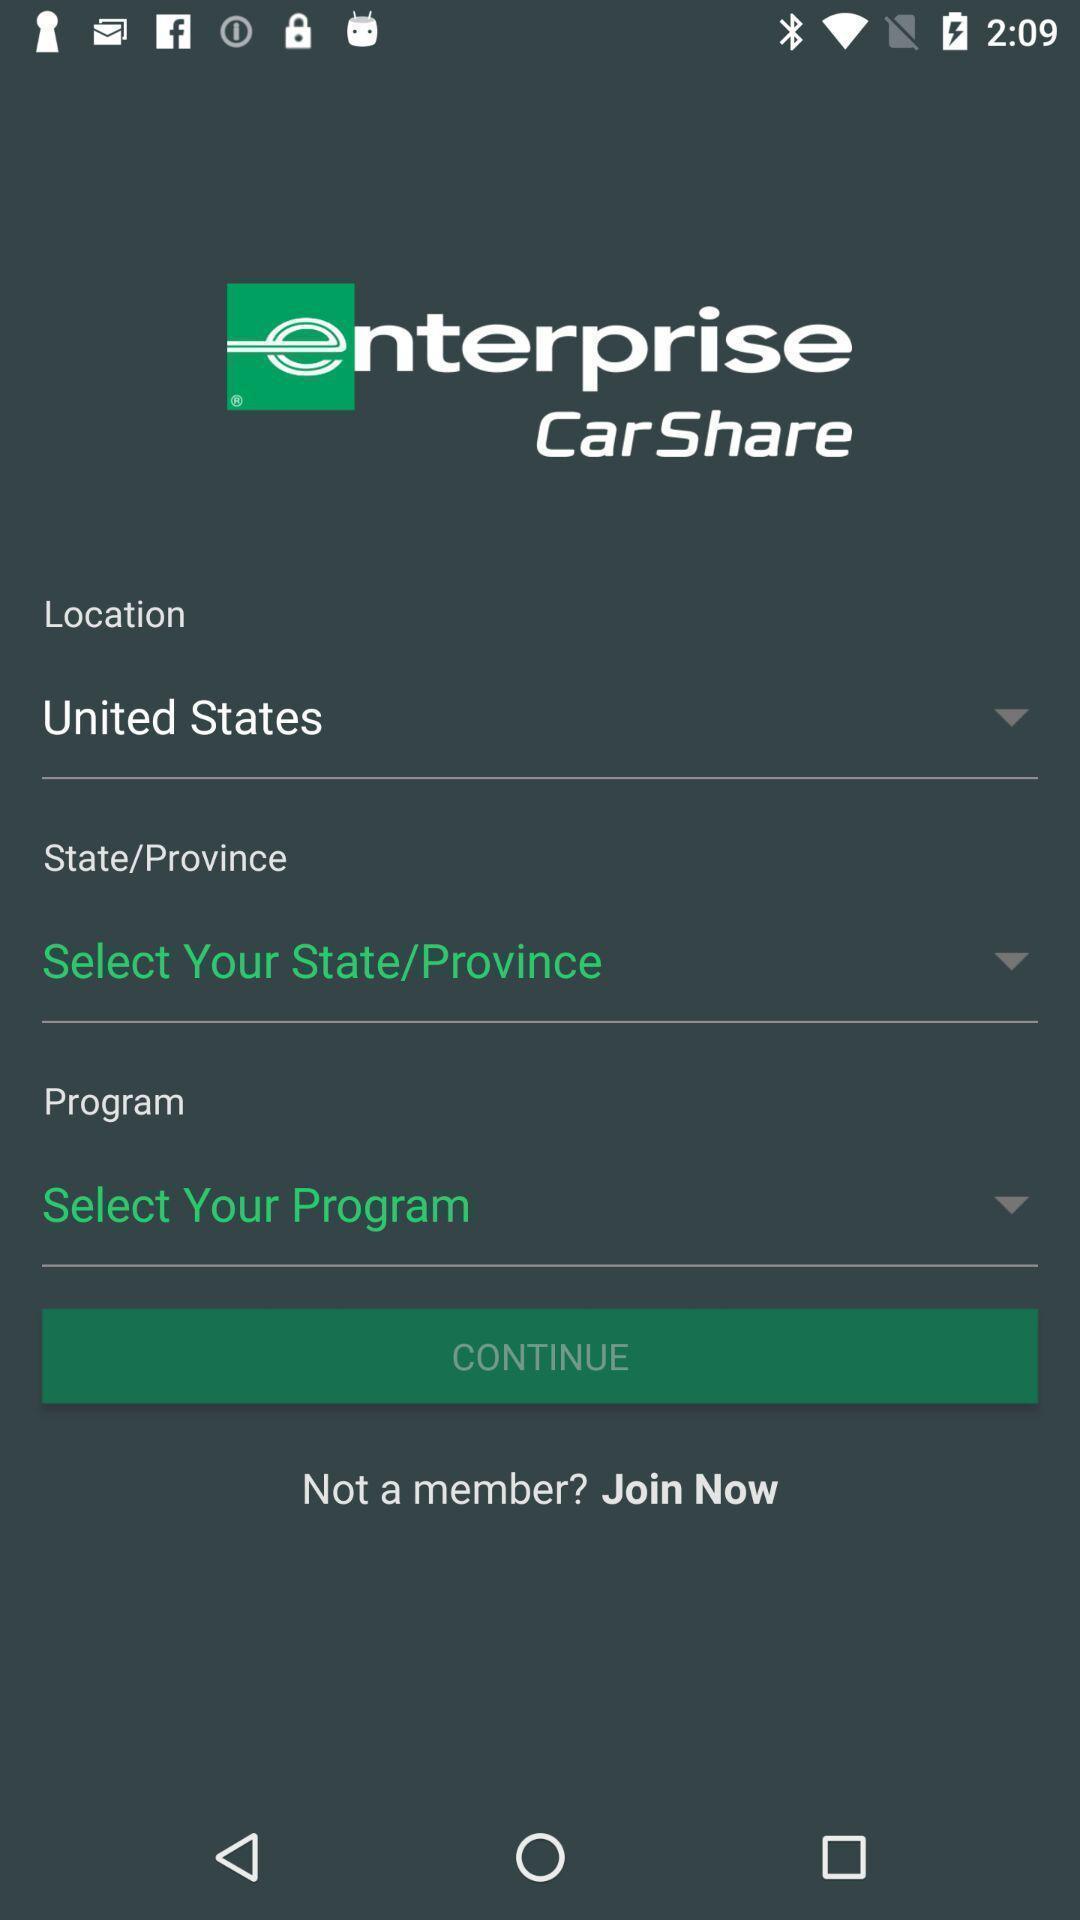Describe the visual elements of this screenshot. Sign in page for an application. 